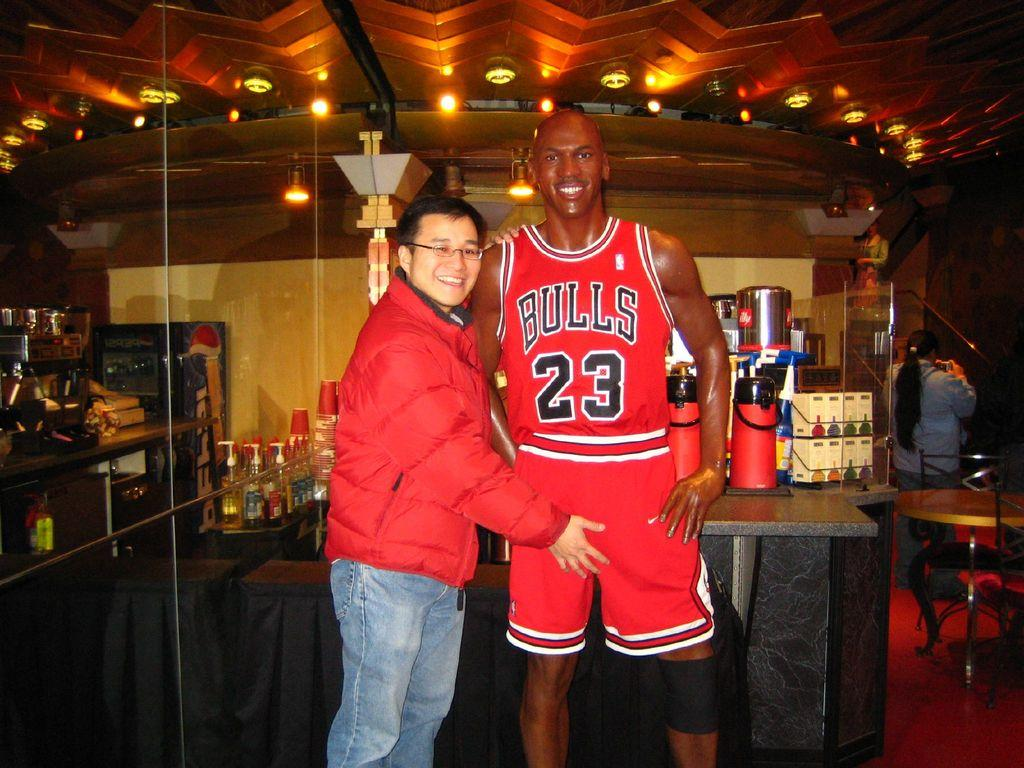<image>
Provide a brief description of the given image. A man grabbing the crotch of Michael Jordan from the Chicago Bulls. 